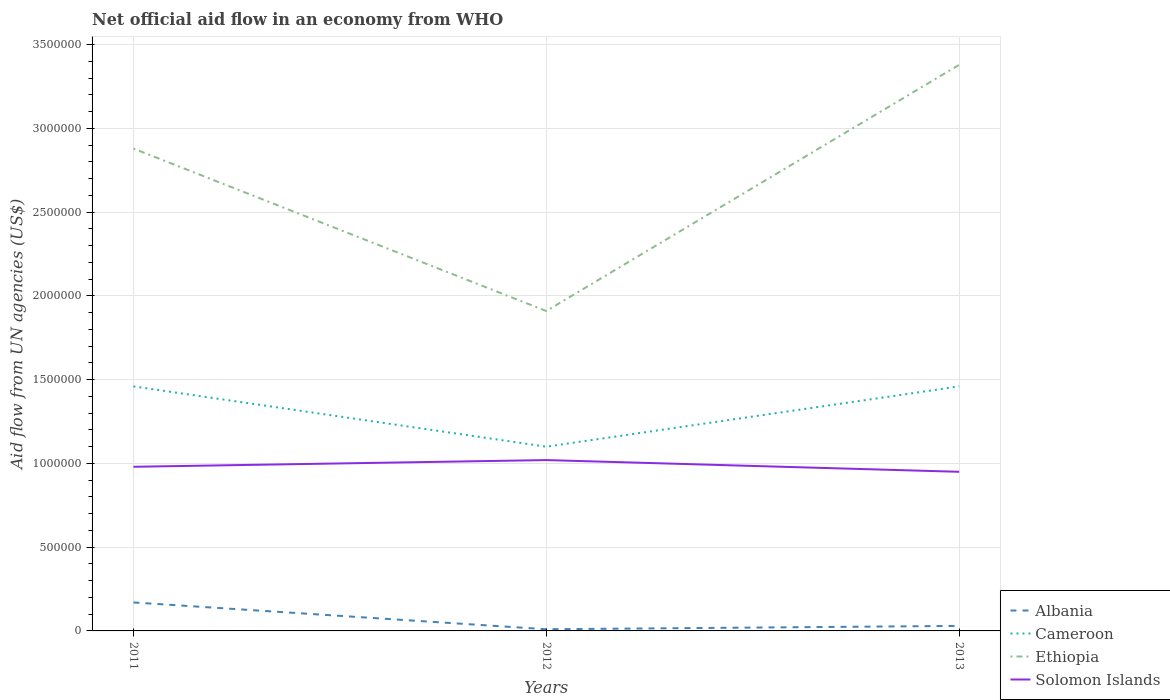How many different coloured lines are there?
Give a very brief answer. 4. Across all years, what is the maximum net official aid flow in Solomon Islands?
Ensure brevity in your answer.  9.50e+05. What is the difference between the highest and the lowest net official aid flow in Solomon Islands?
Make the answer very short. 1. How many lines are there?
Offer a terse response. 4. How many years are there in the graph?
Offer a terse response. 3. Does the graph contain any zero values?
Your answer should be very brief. No. Does the graph contain grids?
Make the answer very short. Yes. How many legend labels are there?
Provide a short and direct response. 4. What is the title of the graph?
Keep it short and to the point. Net official aid flow in an economy from WHO. What is the label or title of the X-axis?
Give a very brief answer. Years. What is the label or title of the Y-axis?
Ensure brevity in your answer.  Aid flow from UN agencies (US$). What is the Aid flow from UN agencies (US$) in Albania in 2011?
Keep it short and to the point. 1.70e+05. What is the Aid flow from UN agencies (US$) of Cameroon in 2011?
Give a very brief answer. 1.46e+06. What is the Aid flow from UN agencies (US$) of Ethiopia in 2011?
Your answer should be very brief. 2.88e+06. What is the Aid flow from UN agencies (US$) of Solomon Islands in 2011?
Make the answer very short. 9.80e+05. What is the Aid flow from UN agencies (US$) of Albania in 2012?
Keep it short and to the point. 10000. What is the Aid flow from UN agencies (US$) in Cameroon in 2012?
Ensure brevity in your answer.  1.10e+06. What is the Aid flow from UN agencies (US$) of Ethiopia in 2012?
Offer a terse response. 1.91e+06. What is the Aid flow from UN agencies (US$) in Solomon Islands in 2012?
Your answer should be very brief. 1.02e+06. What is the Aid flow from UN agencies (US$) in Albania in 2013?
Provide a succinct answer. 3.00e+04. What is the Aid flow from UN agencies (US$) of Cameroon in 2013?
Offer a very short reply. 1.46e+06. What is the Aid flow from UN agencies (US$) in Ethiopia in 2013?
Provide a succinct answer. 3.38e+06. What is the Aid flow from UN agencies (US$) of Solomon Islands in 2013?
Provide a short and direct response. 9.50e+05. Across all years, what is the maximum Aid flow from UN agencies (US$) of Cameroon?
Offer a very short reply. 1.46e+06. Across all years, what is the maximum Aid flow from UN agencies (US$) in Ethiopia?
Your answer should be compact. 3.38e+06. Across all years, what is the maximum Aid flow from UN agencies (US$) in Solomon Islands?
Keep it short and to the point. 1.02e+06. Across all years, what is the minimum Aid flow from UN agencies (US$) in Albania?
Ensure brevity in your answer.  10000. Across all years, what is the minimum Aid flow from UN agencies (US$) in Cameroon?
Offer a very short reply. 1.10e+06. Across all years, what is the minimum Aid flow from UN agencies (US$) of Ethiopia?
Offer a very short reply. 1.91e+06. Across all years, what is the minimum Aid flow from UN agencies (US$) in Solomon Islands?
Your answer should be compact. 9.50e+05. What is the total Aid flow from UN agencies (US$) in Albania in the graph?
Give a very brief answer. 2.10e+05. What is the total Aid flow from UN agencies (US$) in Cameroon in the graph?
Make the answer very short. 4.02e+06. What is the total Aid flow from UN agencies (US$) in Ethiopia in the graph?
Provide a short and direct response. 8.17e+06. What is the total Aid flow from UN agencies (US$) of Solomon Islands in the graph?
Provide a short and direct response. 2.95e+06. What is the difference between the Aid flow from UN agencies (US$) in Albania in 2011 and that in 2012?
Provide a succinct answer. 1.60e+05. What is the difference between the Aid flow from UN agencies (US$) of Ethiopia in 2011 and that in 2012?
Offer a very short reply. 9.70e+05. What is the difference between the Aid flow from UN agencies (US$) in Solomon Islands in 2011 and that in 2012?
Your answer should be compact. -4.00e+04. What is the difference between the Aid flow from UN agencies (US$) in Cameroon in 2011 and that in 2013?
Keep it short and to the point. 0. What is the difference between the Aid flow from UN agencies (US$) of Ethiopia in 2011 and that in 2013?
Your answer should be very brief. -5.00e+05. What is the difference between the Aid flow from UN agencies (US$) of Solomon Islands in 2011 and that in 2013?
Your response must be concise. 3.00e+04. What is the difference between the Aid flow from UN agencies (US$) of Albania in 2012 and that in 2013?
Your response must be concise. -2.00e+04. What is the difference between the Aid flow from UN agencies (US$) in Cameroon in 2012 and that in 2013?
Your answer should be compact. -3.60e+05. What is the difference between the Aid flow from UN agencies (US$) of Ethiopia in 2012 and that in 2013?
Provide a succinct answer. -1.47e+06. What is the difference between the Aid flow from UN agencies (US$) of Albania in 2011 and the Aid flow from UN agencies (US$) of Cameroon in 2012?
Offer a terse response. -9.30e+05. What is the difference between the Aid flow from UN agencies (US$) in Albania in 2011 and the Aid flow from UN agencies (US$) in Ethiopia in 2012?
Provide a short and direct response. -1.74e+06. What is the difference between the Aid flow from UN agencies (US$) of Albania in 2011 and the Aid flow from UN agencies (US$) of Solomon Islands in 2012?
Your answer should be very brief. -8.50e+05. What is the difference between the Aid flow from UN agencies (US$) of Cameroon in 2011 and the Aid flow from UN agencies (US$) of Ethiopia in 2012?
Provide a succinct answer. -4.50e+05. What is the difference between the Aid flow from UN agencies (US$) in Ethiopia in 2011 and the Aid flow from UN agencies (US$) in Solomon Islands in 2012?
Keep it short and to the point. 1.86e+06. What is the difference between the Aid flow from UN agencies (US$) in Albania in 2011 and the Aid flow from UN agencies (US$) in Cameroon in 2013?
Provide a succinct answer. -1.29e+06. What is the difference between the Aid flow from UN agencies (US$) in Albania in 2011 and the Aid flow from UN agencies (US$) in Ethiopia in 2013?
Your answer should be very brief. -3.21e+06. What is the difference between the Aid flow from UN agencies (US$) in Albania in 2011 and the Aid flow from UN agencies (US$) in Solomon Islands in 2013?
Your answer should be very brief. -7.80e+05. What is the difference between the Aid flow from UN agencies (US$) of Cameroon in 2011 and the Aid flow from UN agencies (US$) of Ethiopia in 2013?
Ensure brevity in your answer.  -1.92e+06. What is the difference between the Aid flow from UN agencies (US$) of Cameroon in 2011 and the Aid flow from UN agencies (US$) of Solomon Islands in 2013?
Make the answer very short. 5.10e+05. What is the difference between the Aid flow from UN agencies (US$) of Ethiopia in 2011 and the Aid flow from UN agencies (US$) of Solomon Islands in 2013?
Ensure brevity in your answer.  1.93e+06. What is the difference between the Aid flow from UN agencies (US$) of Albania in 2012 and the Aid flow from UN agencies (US$) of Cameroon in 2013?
Your response must be concise. -1.45e+06. What is the difference between the Aid flow from UN agencies (US$) in Albania in 2012 and the Aid flow from UN agencies (US$) in Ethiopia in 2013?
Ensure brevity in your answer.  -3.37e+06. What is the difference between the Aid flow from UN agencies (US$) in Albania in 2012 and the Aid flow from UN agencies (US$) in Solomon Islands in 2013?
Your answer should be compact. -9.40e+05. What is the difference between the Aid flow from UN agencies (US$) in Cameroon in 2012 and the Aid flow from UN agencies (US$) in Ethiopia in 2013?
Provide a succinct answer. -2.28e+06. What is the difference between the Aid flow from UN agencies (US$) in Ethiopia in 2012 and the Aid flow from UN agencies (US$) in Solomon Islands in 2013?
Your answer should be very brief. 9.60e+05. What is the average Aid flow from UN agencies (US$) of Albania per year?
Ensure brevity in your answer.  7.00e+04. What is the average Aid flow from UN agencies (US$) in Cameroon per year?
Offer a very short reply. 1.34e+06. What is the average Aid flow from UN agencies (US$) of Ethiopia per year?
Ensure brevity in your answer.  2.72e+06. What is the average Aid flow from UN agencies (US$) in Solomon Islands per year?
Ensure brevity in your answer.  9.83e+05. In the year 2011, what is the difference between the Aid flow from UN agencies (US$) in Albania and Aid flow from UN agencies (US$) in Cameroon?
Provide a succinct answer. -1.29e+06. In the year 2011, what is the difference between the Aid flow from UN agencies (US$) in Albania and Aid flow from UN agencies (US$) in Ethiopia?
Ensure brevity in your answer.  -2.71e+06. In the year 2011, what is the difference between the Aid flow from UN agencies (US$) of Albania and Aid flow from UN agencies (US$) of Solomon Islands?
Your answer should be very brief. -8.10e+05. In the year 2011, what is the difference between the Aid flow from UN agencies (US$) in Cameroon and Aid flow from UN agencies (US$) in Ethiopia?
Provide a succinct answer. -1.42e+06. In the year 2011, what is the difference between the Aid flow from UN agencies (US$) of Ethiopia and Aid flow from UN agencies (US$) of Solomon Islands?
Your answer should be compact. 1.90e+06. In the year 2012, what is the difference between the Aid flow from UN agencies (US$) in Albania and Aid flow from UN agencies (US$) in Cameroon?
Make the answer very short. -1.09e+06. In the year 2012, what is the difference between the Aid flow from UN agencies (US$) in Albania and Aid flow from UN agencies (US$) in Ethiopia?
Ensure brevity in your answer.  -1.90e+06. In the year 2012, what is the difference between the Aid flow from UN agencies (US$) in Albania and Aid flow from UN agencies (US$) in Solomon Islands?
Offer a terse response. -1.01e+06. In the year 2012, what is the difference between the Aid flow from UN agencies (US$) in Cameroon and Aid flow from UN agencies (US$) in Ethiopia?
Offer a terse response. -8.10e+05. In the year 2012, what is the difference between the Aid flow from UN agencies (US$) of Ethiopia and Aid flow from UN agencies (US$) of Solomon Islands?
Ensure brevity in your answer.  8.90e+05. In the year 2013, what is the difference between the Aid flow from UN agencies (US$) in Albania and Aid flow from UN agencies (US$) in Cameroon?
Your response must be concise. -1.43e+06. In the year 2013, what is the difference between the Aid flow from UN agencies (US$) in Albania and Aid flow from UN agencies (US$) in Ethiopia?
Provide a short and direct response. -3.35e+06. In the year 2013, what is the difference between the Aid flow from UN agencies (US$) of Albania and Aid flow from UN agencies (US$) of Solomon Islands?
Offer a terse response. -9.20e+05. In the year 2013, what is the difference between the Aid flow from UN agencies (US$) in Cameroon and Aid flow from UN agencies (US$) in Ethiopia?
Provide a short and direct response. -1.92e+06. In the year 2013, what is the difference between the Aid flow from UN agencies (US$) in Cameroon and Aid flow from UN agencies (US$) in Solomon Islands?
Provide a short and direct response. 5.10e+05. In the year 2013, what is the difference between the Aid flow from UN agencies (US$) in Ethiopia and Aid flow from UN agencies (US$) in Solomon Islands?
Your answer should be very brief. 2.43e+06. What is the ratio of the Aid flow from UN agencies (US$) of Cameroon in 2011 to that in 2012?
Offer a very short reply. 1.33. What is the ratio of the Aid flow from UN agencies (US$) in Ethiopia in 2011 to that in 2012?
Keep it short and to the point. 1.51. What is the ratio of the Aid flow from UN agencies (US$) in Solomon Islands in 2011 to that in 2012?
Provide a short and direct response. 0.96. What is the ratio of the Aid flow from UN agencies (US$) in Albania in 2011 to that in 2013?
Give a very brief answer. 5.67. What is the ratio of the Aid flow from UN agencies (US$) in Cameroon in 2011 to that in 2013?
Ensure brevity in your answer.  1. What is the ratio of the Aid flow from UN agencies (US$) in Ethiopia in 2011 to that in 2013?
Provide a succinct answer. 0.85. What is the ratio of the Aid flow from UN agencies (US$) in Solomon Islands in 2011 to that in 2013?
Your answer should be very brief. 1.03. What is the ratio of the Aid flow from UN agencies (US$) of Cameroon in 2012 to that in 2013?
Ensure brevity in your answer.  0.75. What is the ratio of the Aid flow from UN agencies (US$) in Ethiopia in 2012 to that in 2013?
Your response must be concise. 0.57. What is the ratio of the Aid flow from UN agencies (US$) of Solomon Islands in 2012 to that in 2013?
Your answer should be compact. 1.07. What is the difference between the highest and the second highest Aid flow from UN agencies (US$) of Albania?
Give a very brief answer. 1.40e+05. What is the difference between the highest and the second highest Aid flow from UN agencies (US$) in Cameroon?
Ensure brevity in your answer.  0. What is the difference between the highest and the second highest Aid flow from UN agencies (US$) in Ethiopia?
Ensure brevity in your answer.  5.00e+05. What is the difference between the highest and the second highest Aid flow from UN agencies (US$) of Solomon Islands?
Your answer should be very brief. 4.00e+04. What is the difference between the highest and the lowest Aid flow from UN agencies (US$) of Albania?
Make the answer very short. 1.60e+05. What is the difference between the highest and the lowest Aid flow from UN agencies (US$) of Cameroon?
Provide a short and direct response. 3.60e+05. What is the difference between the highest and the lowest Aid flow from UN agencies (US$) in Ethiopia?
Your answer should be very brief. 1.47e+06. What is the difference between the highest and the lowest Aid flow from UN agencies (US$) of Solomon Islands?
Provide a short and direct response. 7.00e+04. 